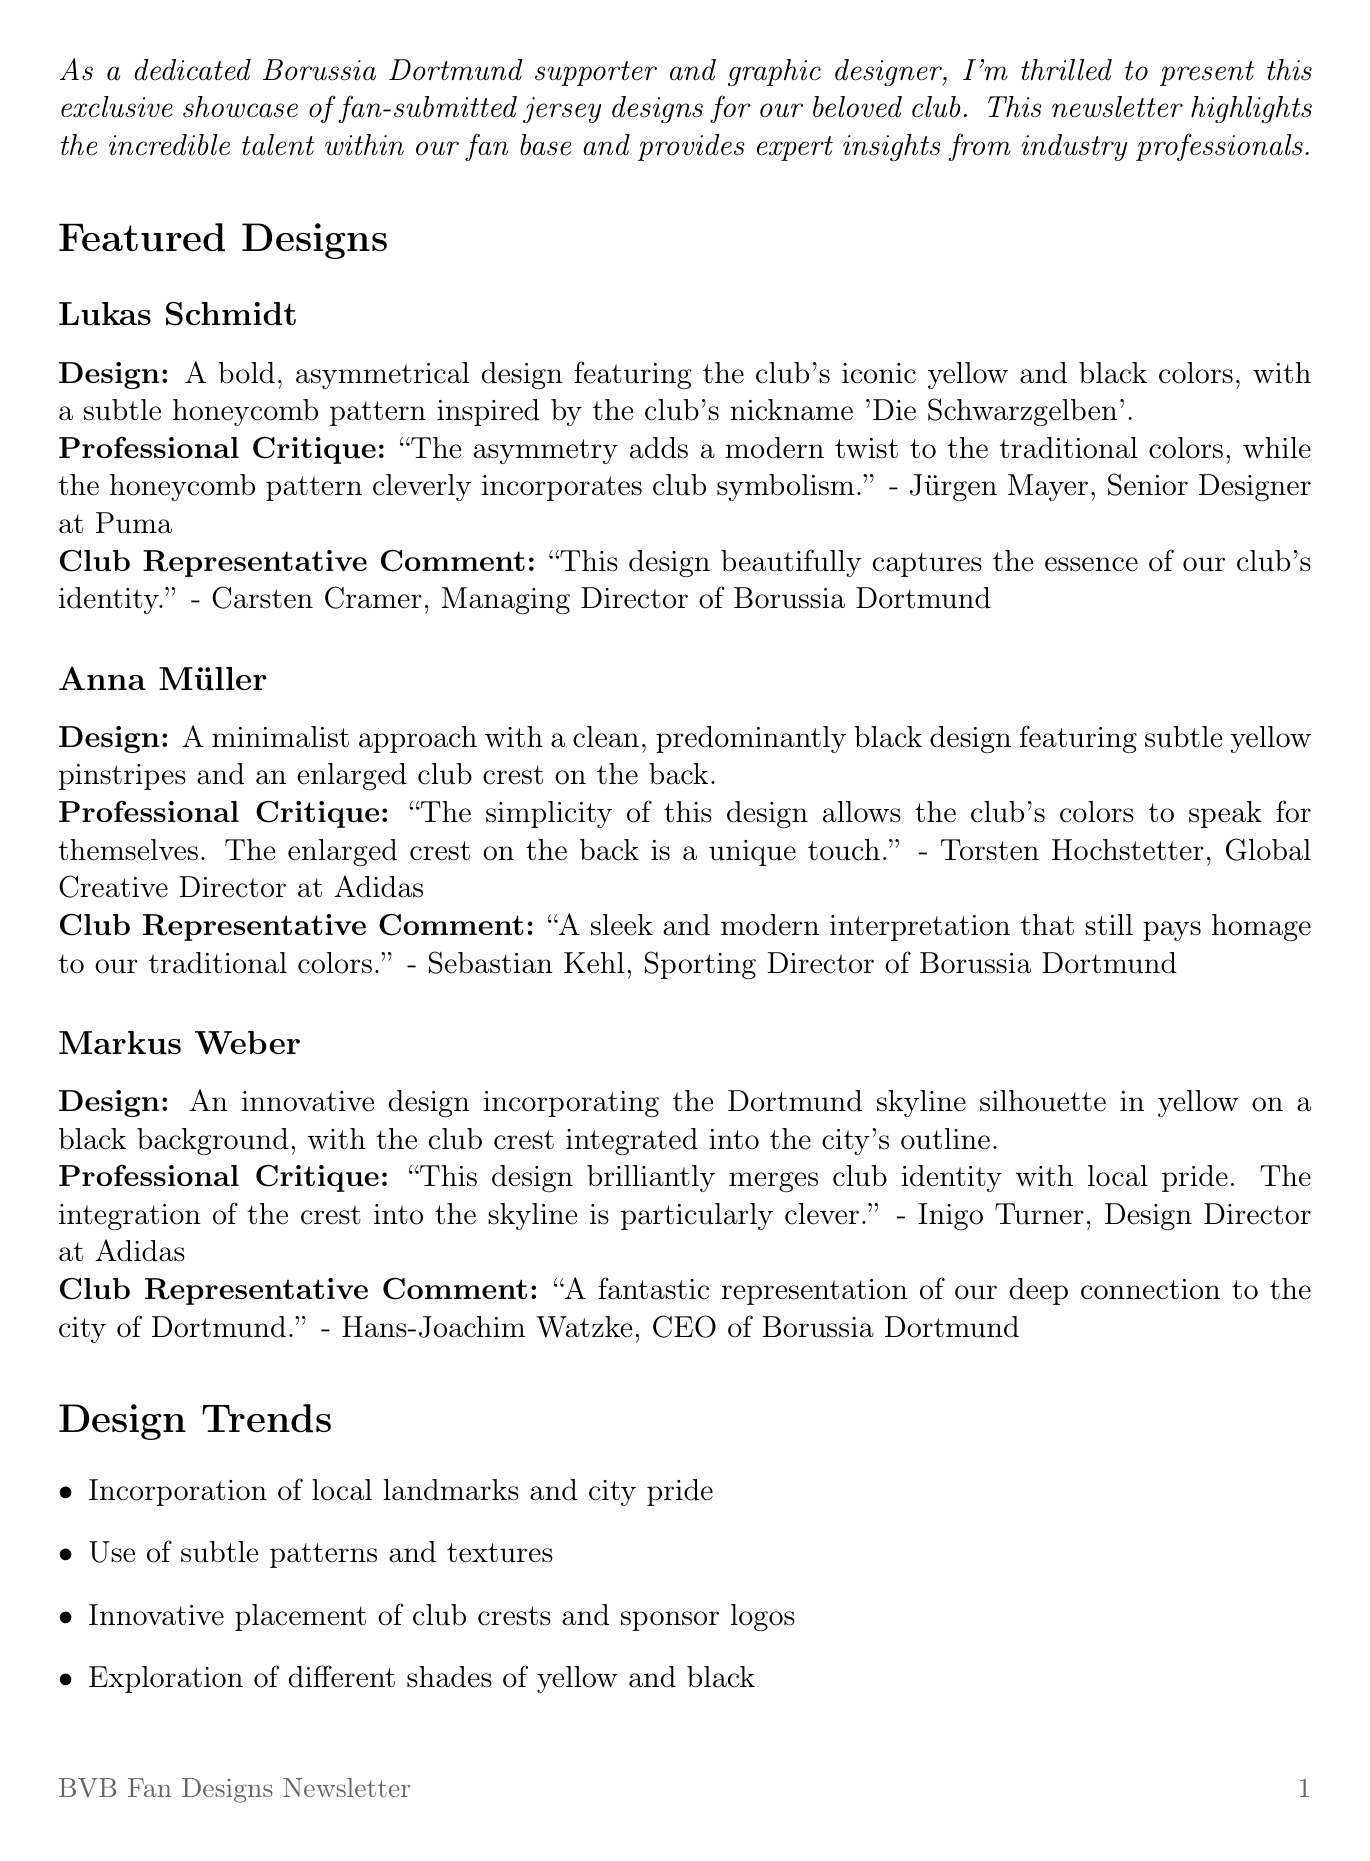What is the title of the newsletter? The title is explicitly stated at the beginning of the newsletter.
Answer: BVB Fan Designs: A Showcase of Passion and Creativity Who designed the jersey with the skyline silhouette? The designer's name is mentioned alongside the design description in the featured designs section.
Answer: Markus Weber What is the submission deadline for the design challenge? The deadline is provided in the fan engagement section of the newsletter.
Answer: August 15, 2023 What color is predominantly used in Anna Müller’s design? The color scheme is detailed in the description of the design.
Answer: Black Which designer used a honeycomb pattern in their design? The specific details of each design include the use of patterns.
Answer: Lukas Schmidt 